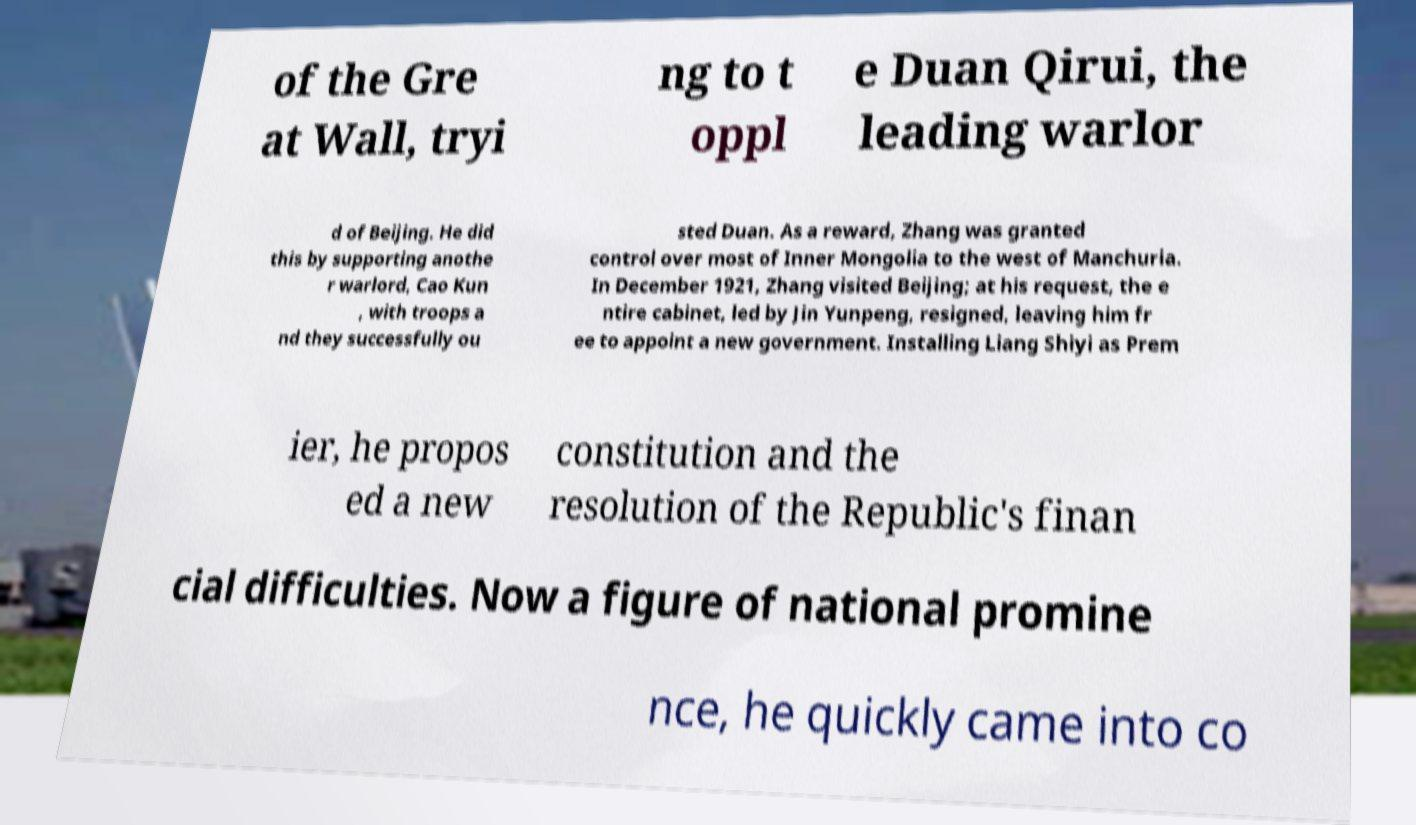What messages or text are displayed in this image? I need them in a readable, typed format. of the Gre at Wall, tryi ng to t oppl e Duan Qirui, the leading warlor d of Beijing. He did this by supporting anothe r warlord, Cao Kun , with troops a nd they successfully ou sted Duan. As a reward, Zhang was granted control over most of Inner Mongolia to the west of Manchuria. In December 1921, Zhang visited Beijing; at his request, the e ntire cabinet, led by Jin Yunpeng, resigned, leaving him fr ee to appoint a new government. Installing Liang Shiyi as Prem ier, he propos ed a new constitution and the resolution of the Republic's finan cial difficulties. Now a figure of national promine nce, he quickly came into co 